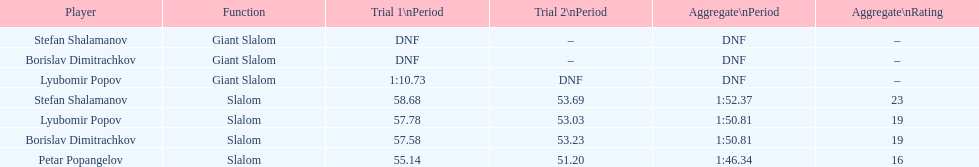What is the number of athletes to finish race one in the giant slalom? 1. 